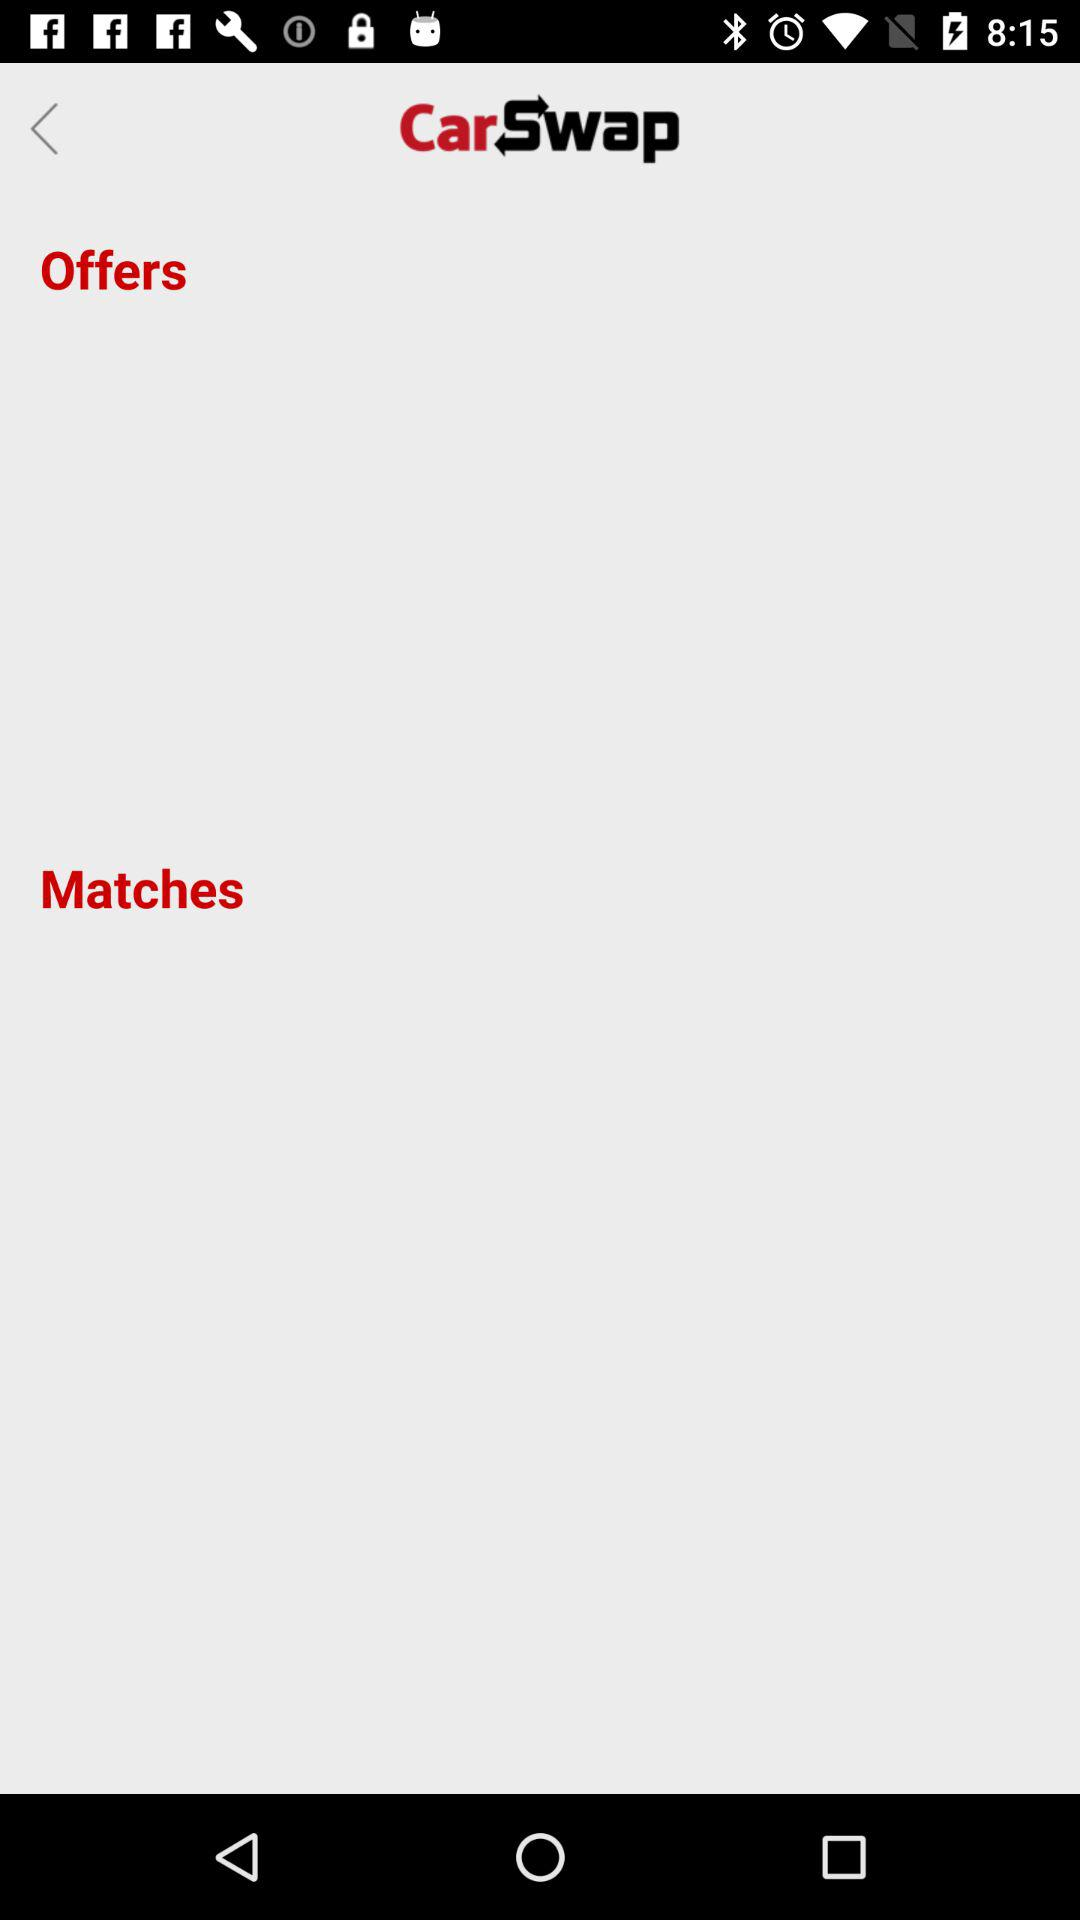What is the name of the application? The name of the application is "CarSwap". 